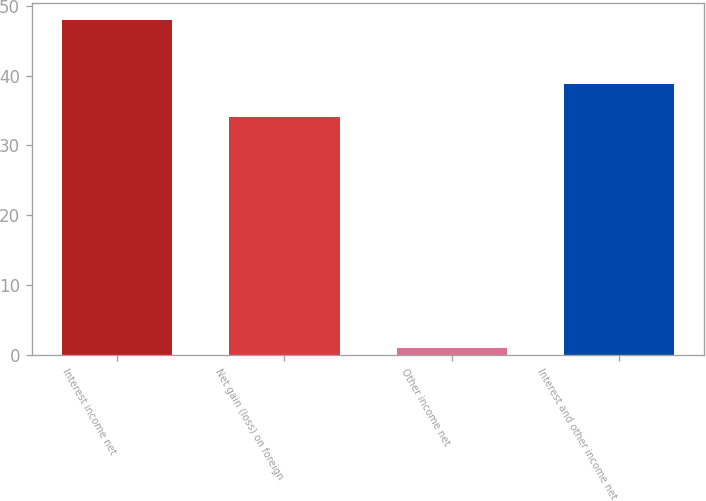Convert chart to OTSL. <chart><loc_0><loc_0><loc_500><loc_500><bar_chart><fcel>Interest income net<fcel>Net gain (loss) on foreign<fcel>Other income net<fcel>Interest and other income net<nl><fcel>48<fcel>34<fcel>1<fcel>38.8<nl></chart> 